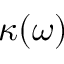Convert formula to latex. <formula><loc_0><loc_0><loc_500><loc_500>\kappa ( \omega )</formula> 